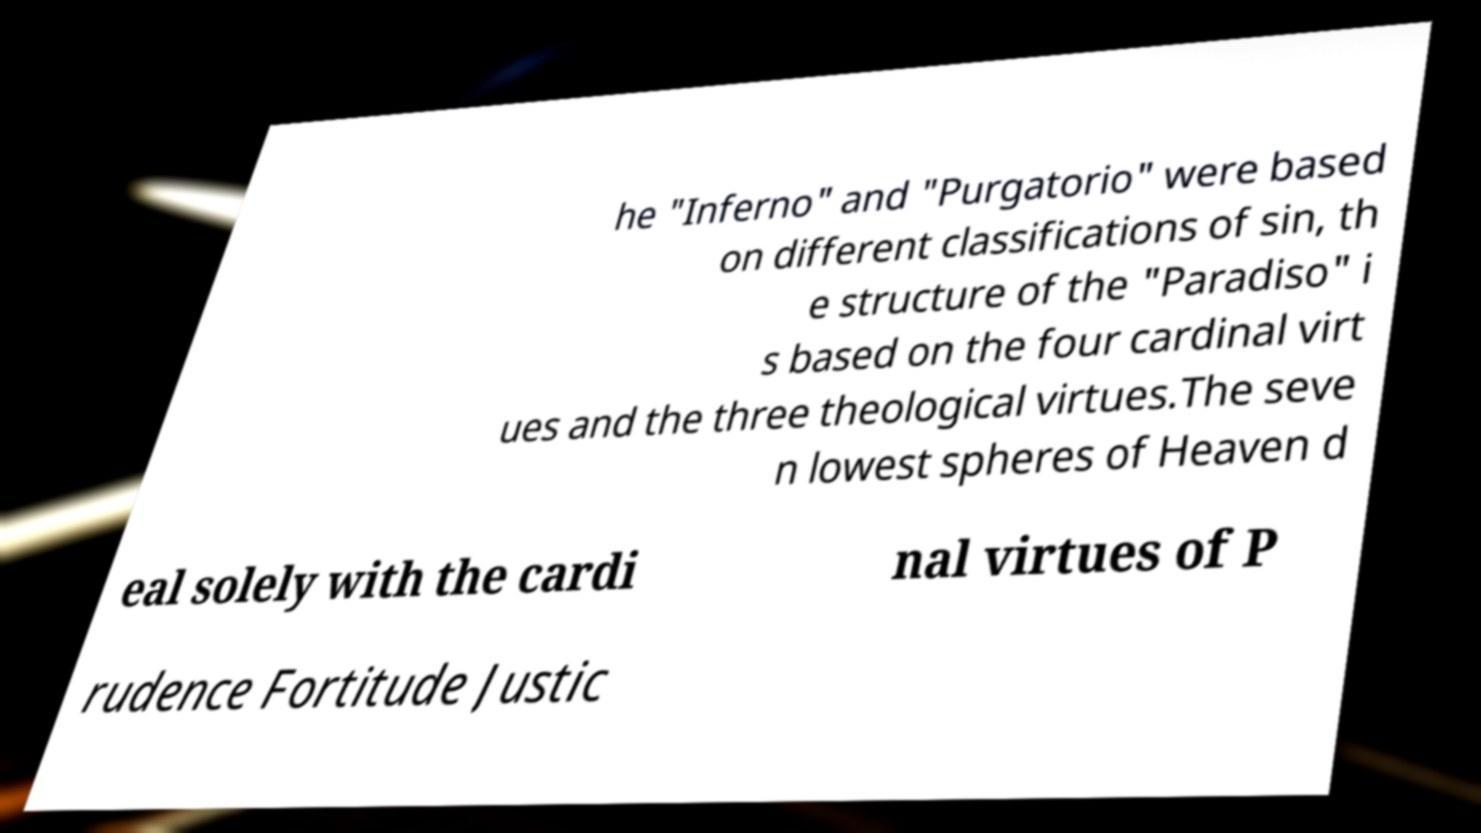Please read and relay the text visible in this image. What does it say? he "Inferno" and "Purgatorio" were based on different classifications of sin, th e structure of the "Paradiso" i s based on the four cardinal virt ues and the three theological virtues.The seve n lowest spheres of Heaven d eal solely with the cardi nal virtues of P rudence Fortitude Justic 